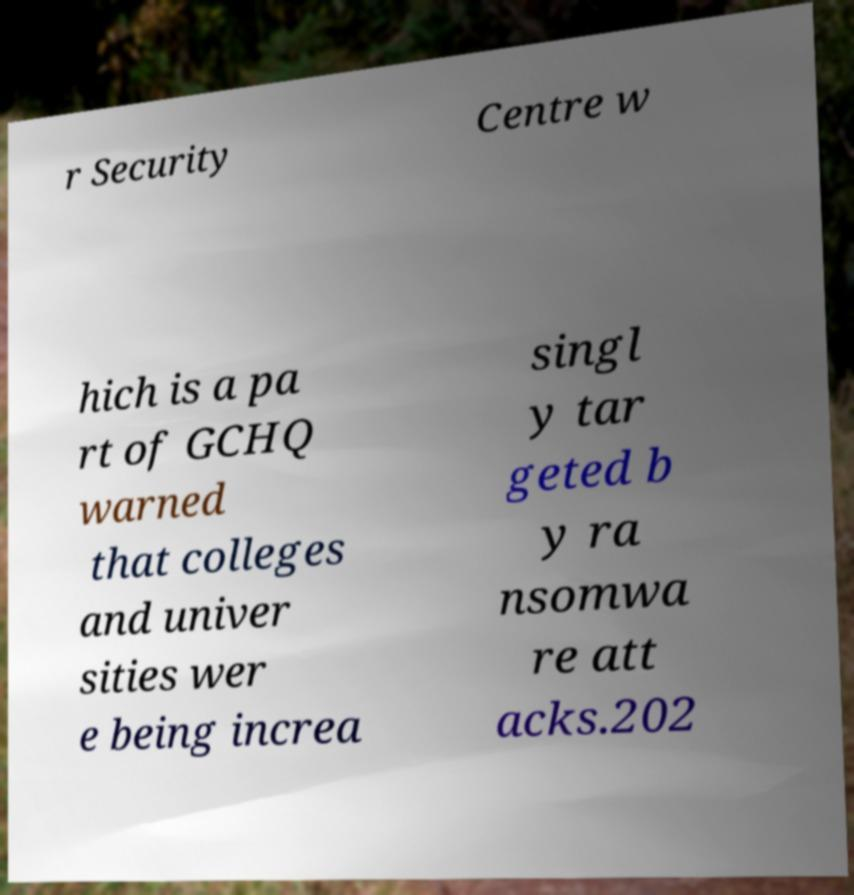What messages or text are displayed in this image? I need them in a readable, typed format. r Security Centre w hich is a pa rt of GCHQ warned that colleges and univer sities wer e being increa singl y tar geted b y ra nsomwa re att acks.202 